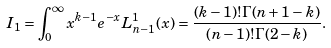Convert formula to latex. <formula><loc_0><loc_0><loc_500><loc_500>I _ { 1 } = \int _ { 0 } ^ { \infty } x ^ { k - 1 } e ^ { - x } L ^ { 1 } _ { n - 1 } ( x ) = \frac { ( k - 1 ) ! \Gamma ( n + 1 - k ) } { ( n - 1 ) ! \Gamma ( 2 - k ) } .</formula> 